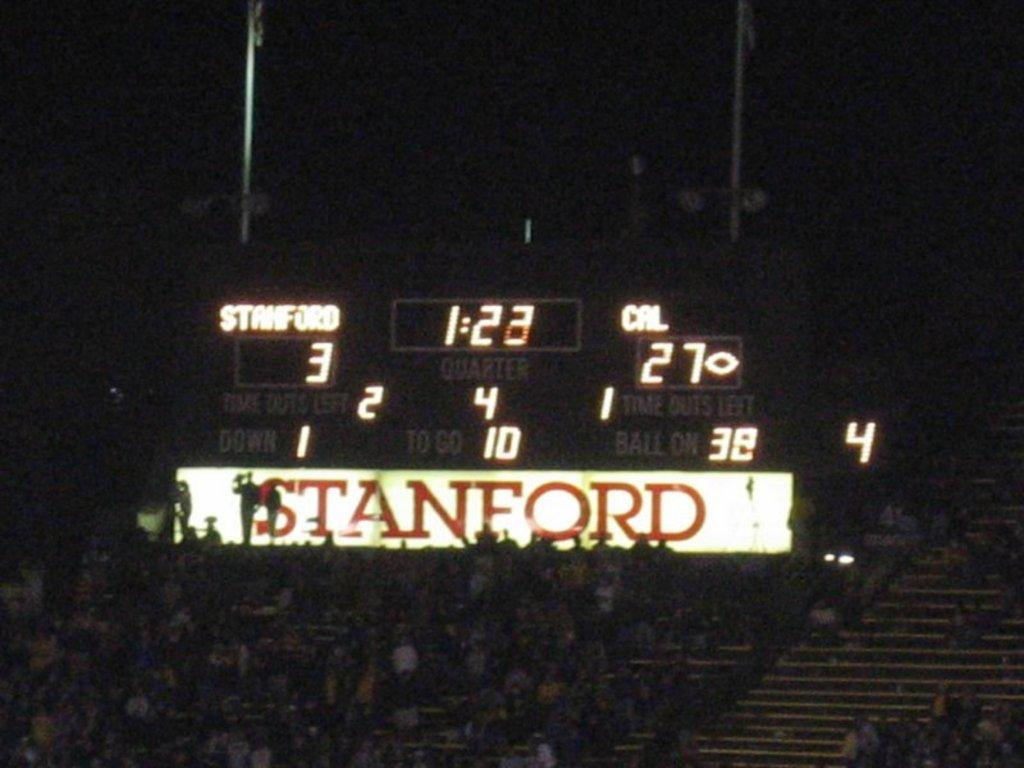<image>
Render a clear and concise summary of the photo. A scoreboard illuminated at night shows Stanford losing to Cal by 24 points. 